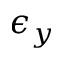<formula> <loc_0><loc_0><loc_500><loc_500>\epsilon _ { y }</formula> 